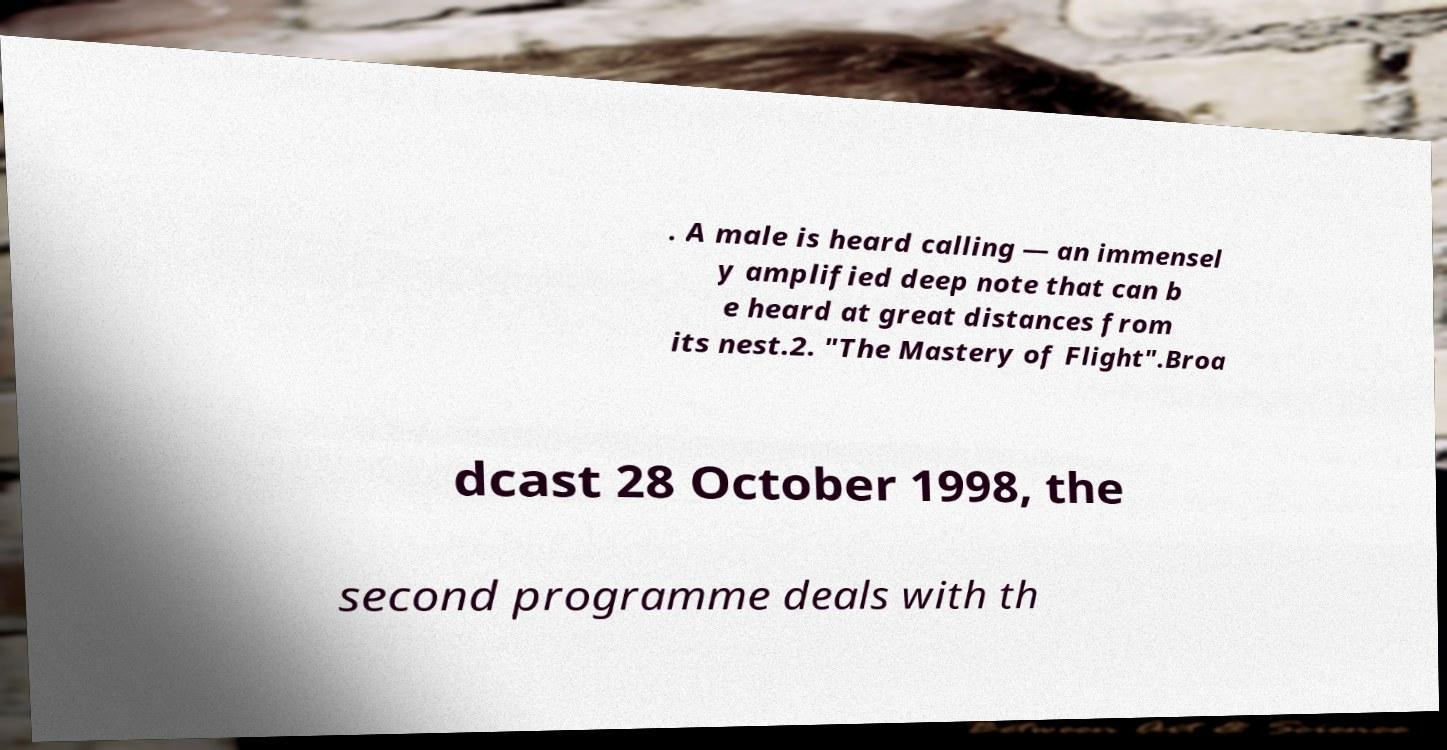Could you assist in decoding the text presented in this image and type it out clearly? . A male is heard calling — an immensel y amplified deep note that can b e heard at great distances from its nest.2. "The Mastery of Flight".Broa dcast 28 October 1998, the second programme deals with th 